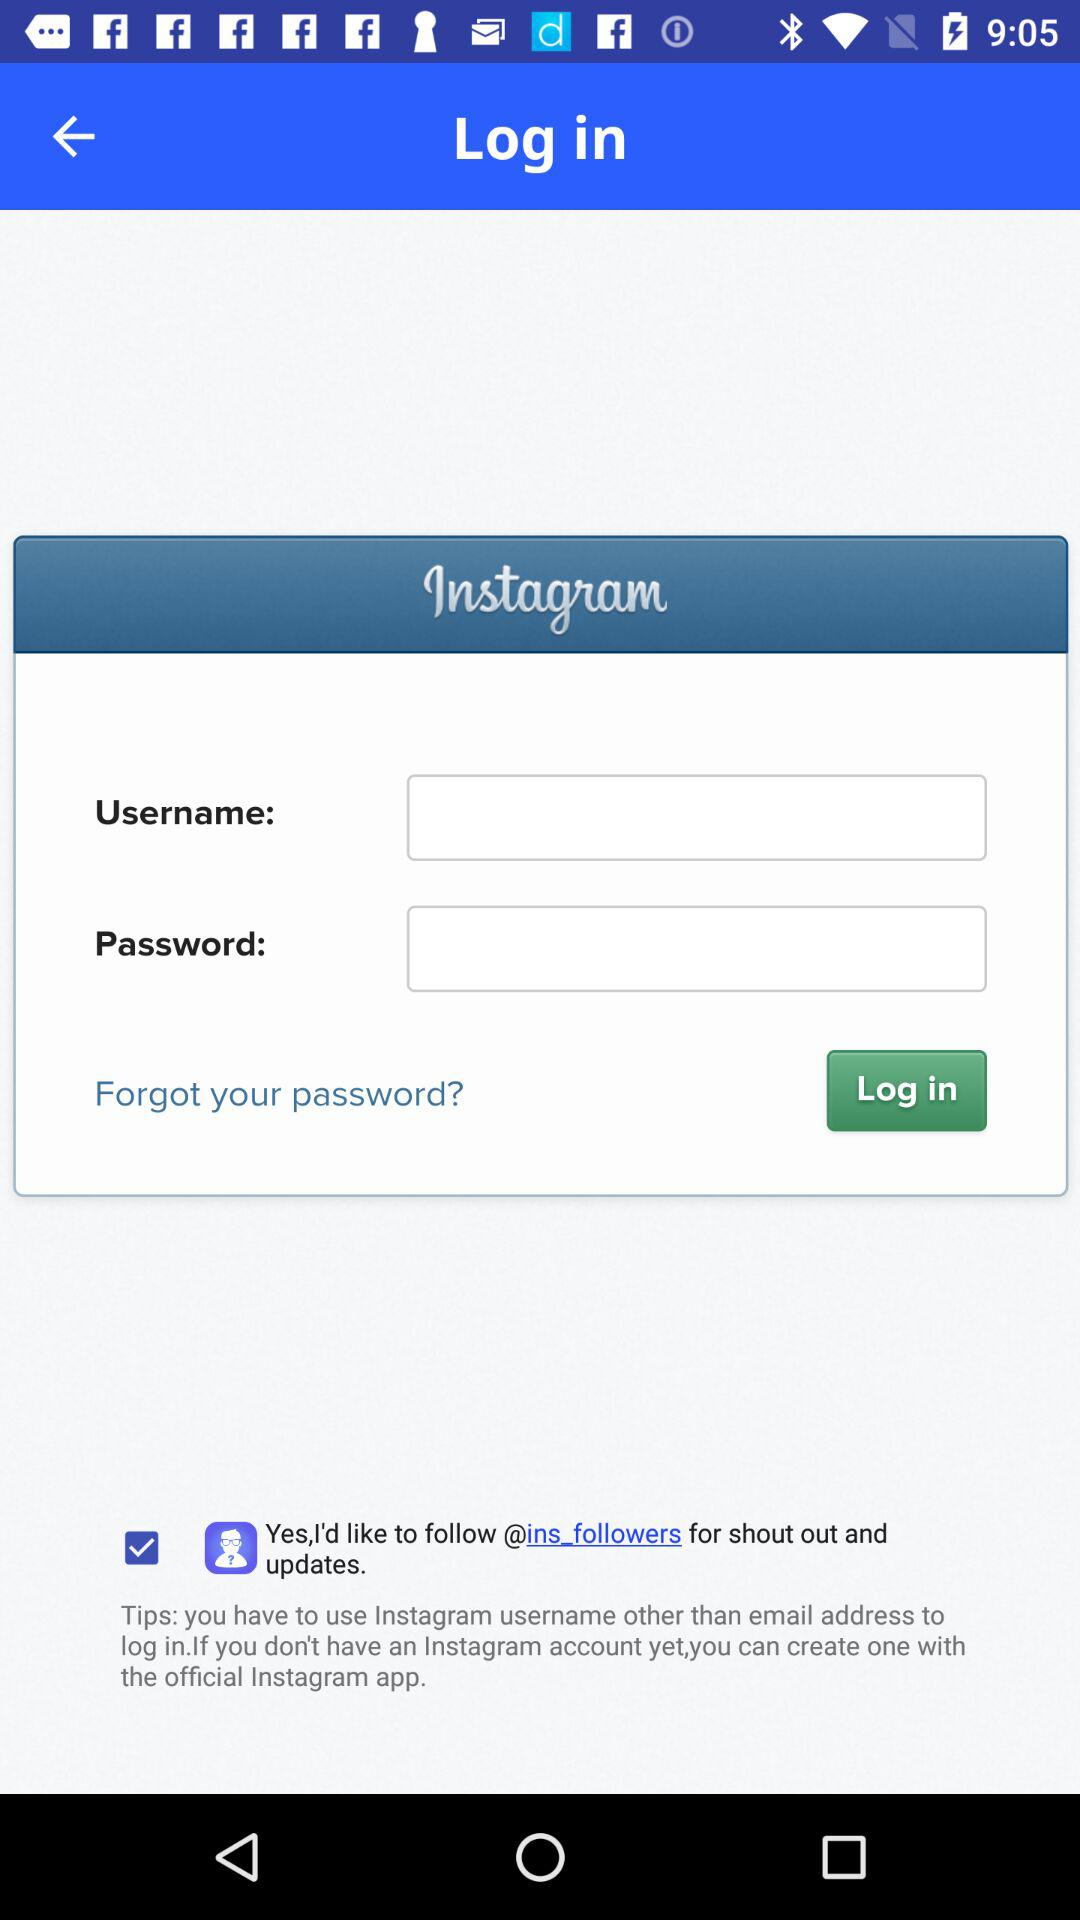Through what application can we log in? You can log in through "Instagram". 